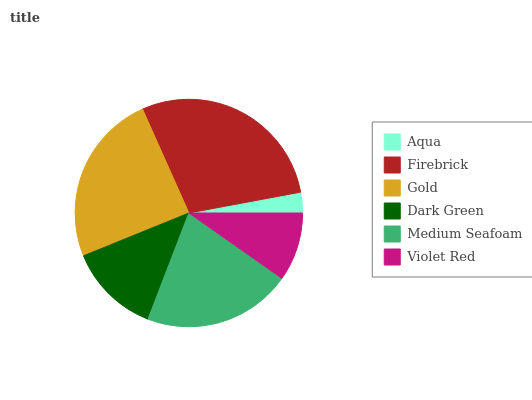Is Aqua the minimum?
Answer yes or no. Yes. Is Firebrick the maximum?
Answer yes or no. Yes. Is Gold the minimum?
Answer yes or no. No. Is Gold the maximum?
Answer yes or no. No. Is Firebrick greater than Gold?
Answer yes or no. Yes. Is Gold less than Firebrick?
Answer yes or no. Yes. Is Gold greater than Firebrick?
Answer yes or no. No. Is Firebrick less than Gold?
Answer yes or no. No. Is Medium Seafoam the high median?
Answer yes or no. Yes. Is Dark Green the low median?
Answer yes or no. Yes. Is Aqua the high median?
Answer yes or no. No. Is Gold the low median?
Answer yes or no. No. 